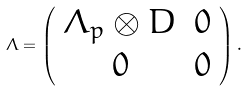Convert formula to latex. <formula><loc_0><loc_0><loc_500><loc_500>\Lambda = \left ( \begin{array} { c c } { { \Lambda _ { p } \otimes D } } & { 0 } \\ { 0 } & { 0 } \end{array} \right ) .</formula> 